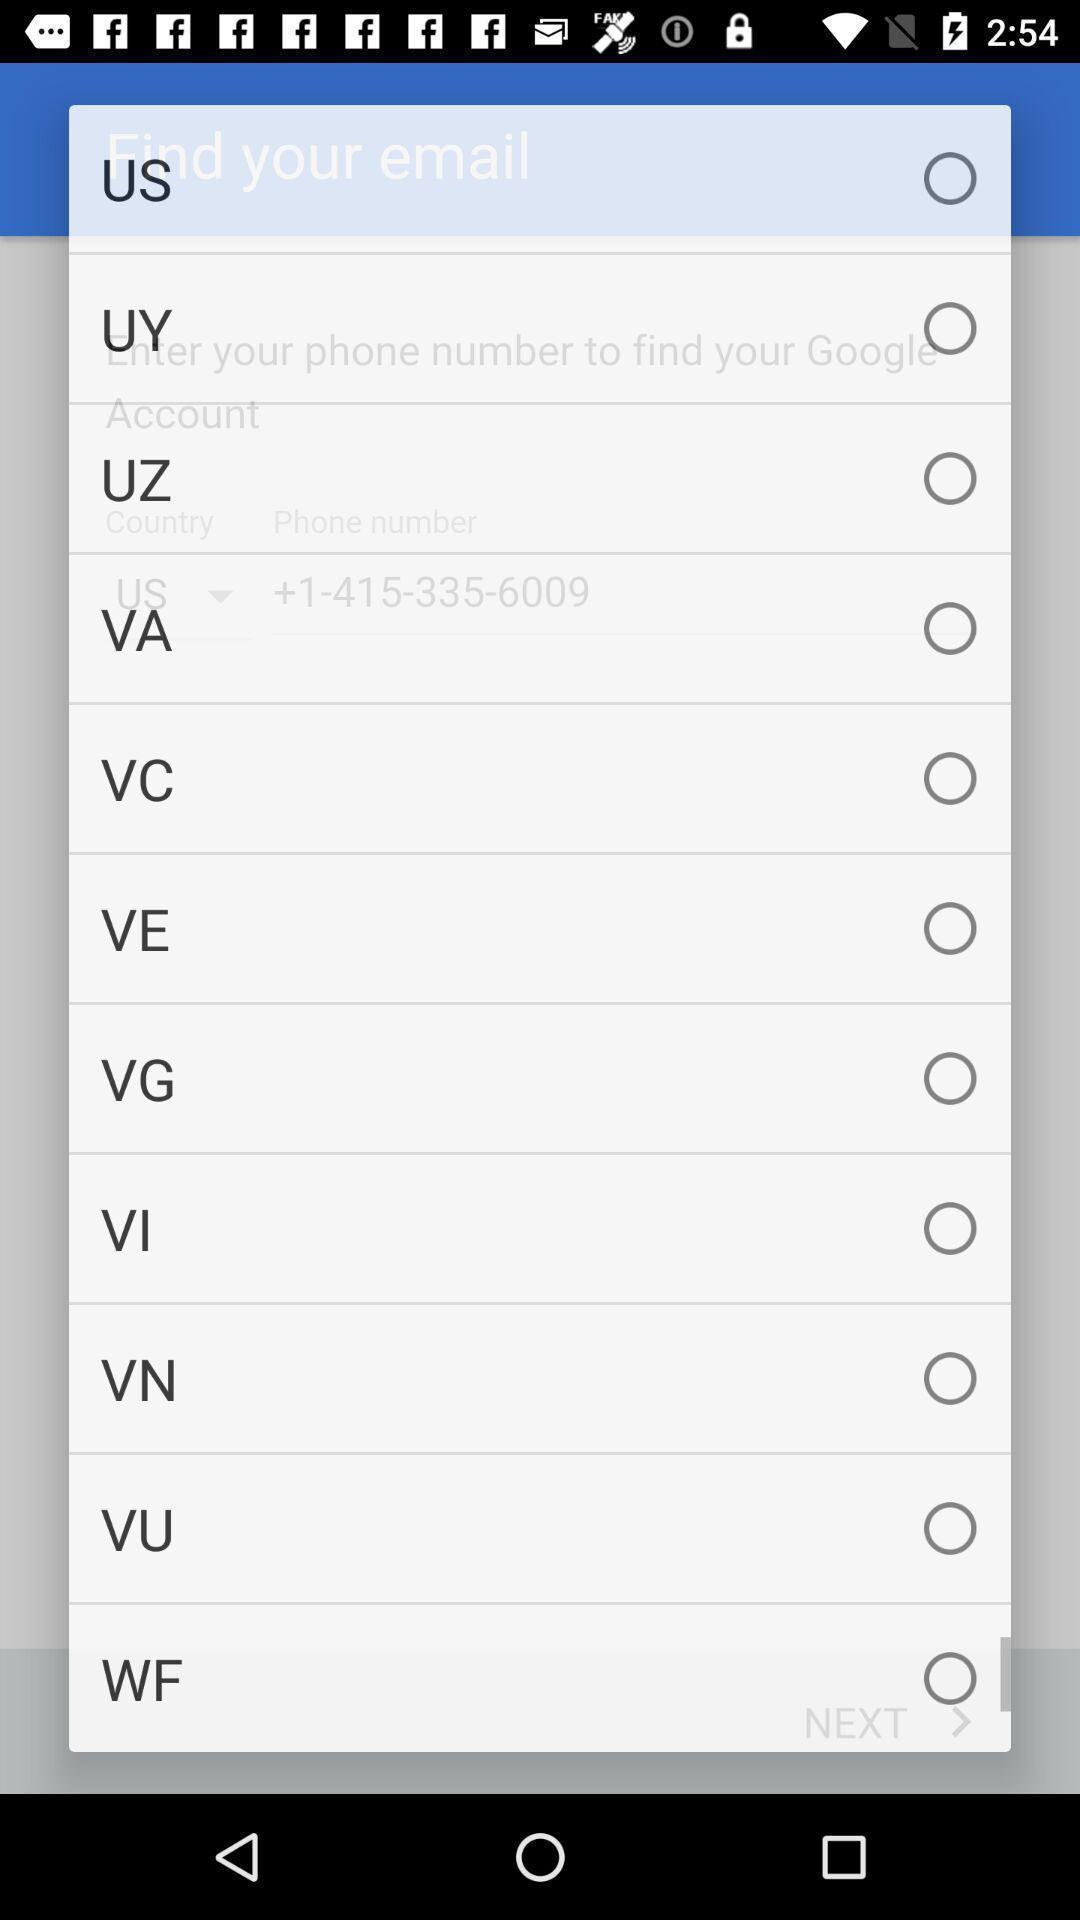Explain the elements present in this screenshot. Pop-up displaying with various country codes. 